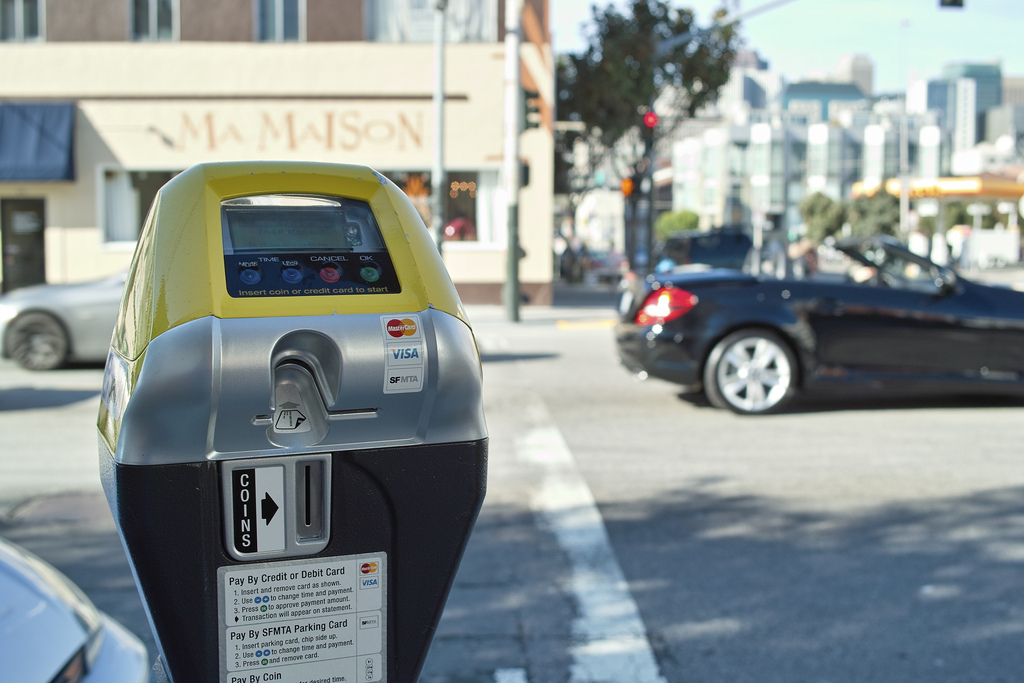Which place is it? The place depicted is a street. 